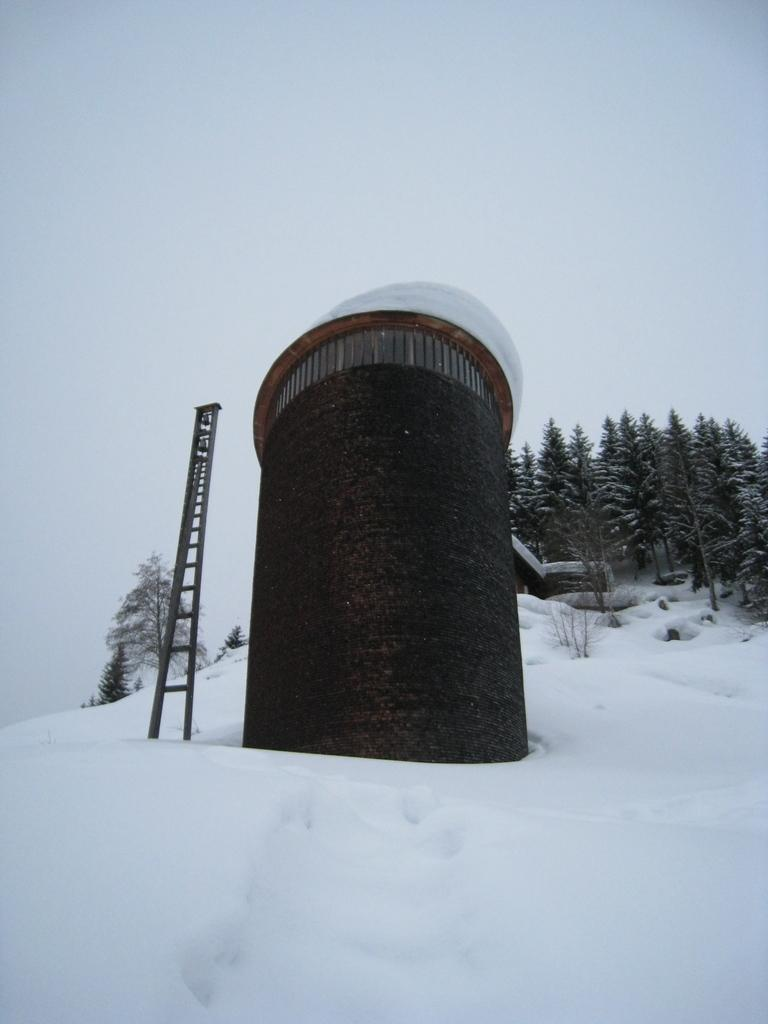What structure is the main focus of the image? There is a tower in the image. What object is present that might be used for climbing? There is a ladder in the image. What type of weather is depicted in the image? There is snow visible in the image, indicating cold weather. What can be seen in the background of the image? There are trees in the background of the image. What is visible at the top of the image? The sky is visible at the top of the image. How many rings are hanging from the curtain in the image? There is no curtain present in the image, and therefore no rings can be observed. 